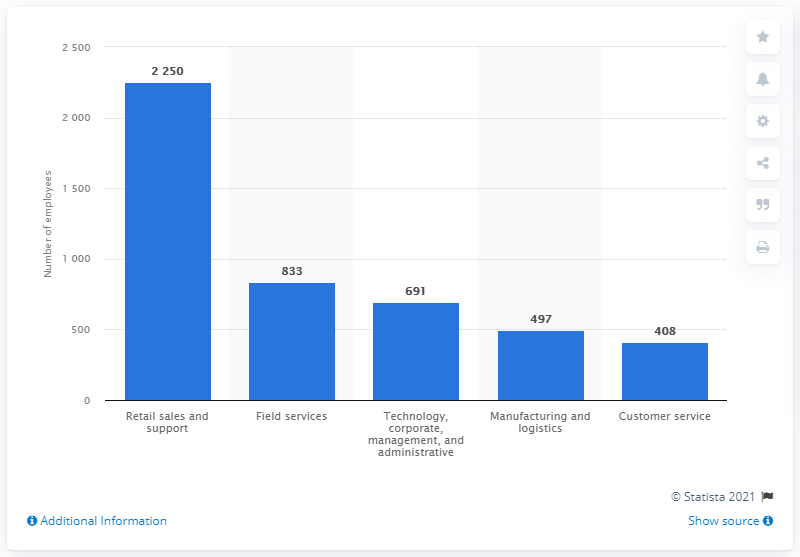Outline some significant characteristics in this image. In 2020, Sleep Number Corporation employed a total of 691 people. 